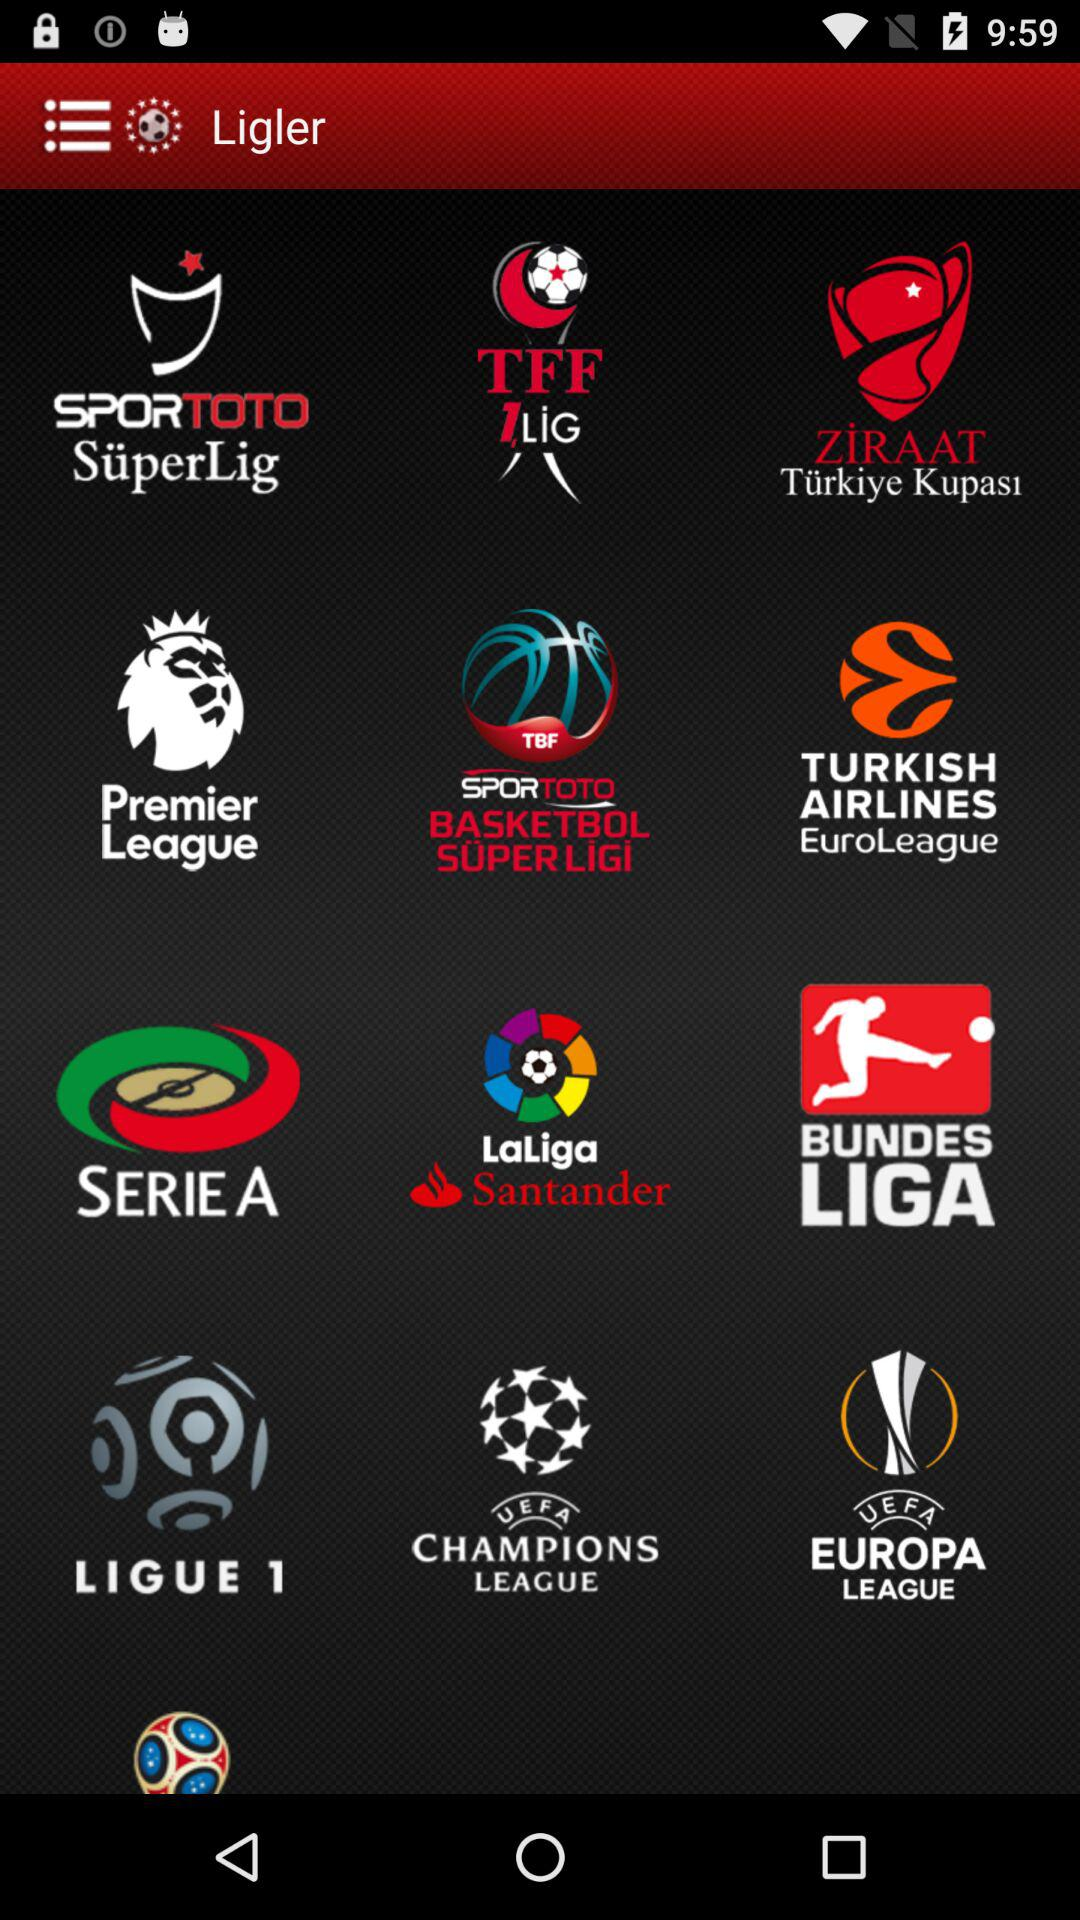What is the name of the application? The name of the application is "Ligler". 